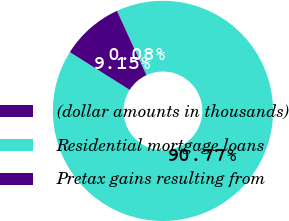Convert chart. <chart><loc_0><loc_0><loc_500><loc_500><pie_chart><fcel>(dollar amounts in thousands)<fcel>Residential mortgage loans<fcel>Pretax gains resulting from<nl><fcel>0.08%<fcel>90.77%<fcel>9.15%<nl></chart> 